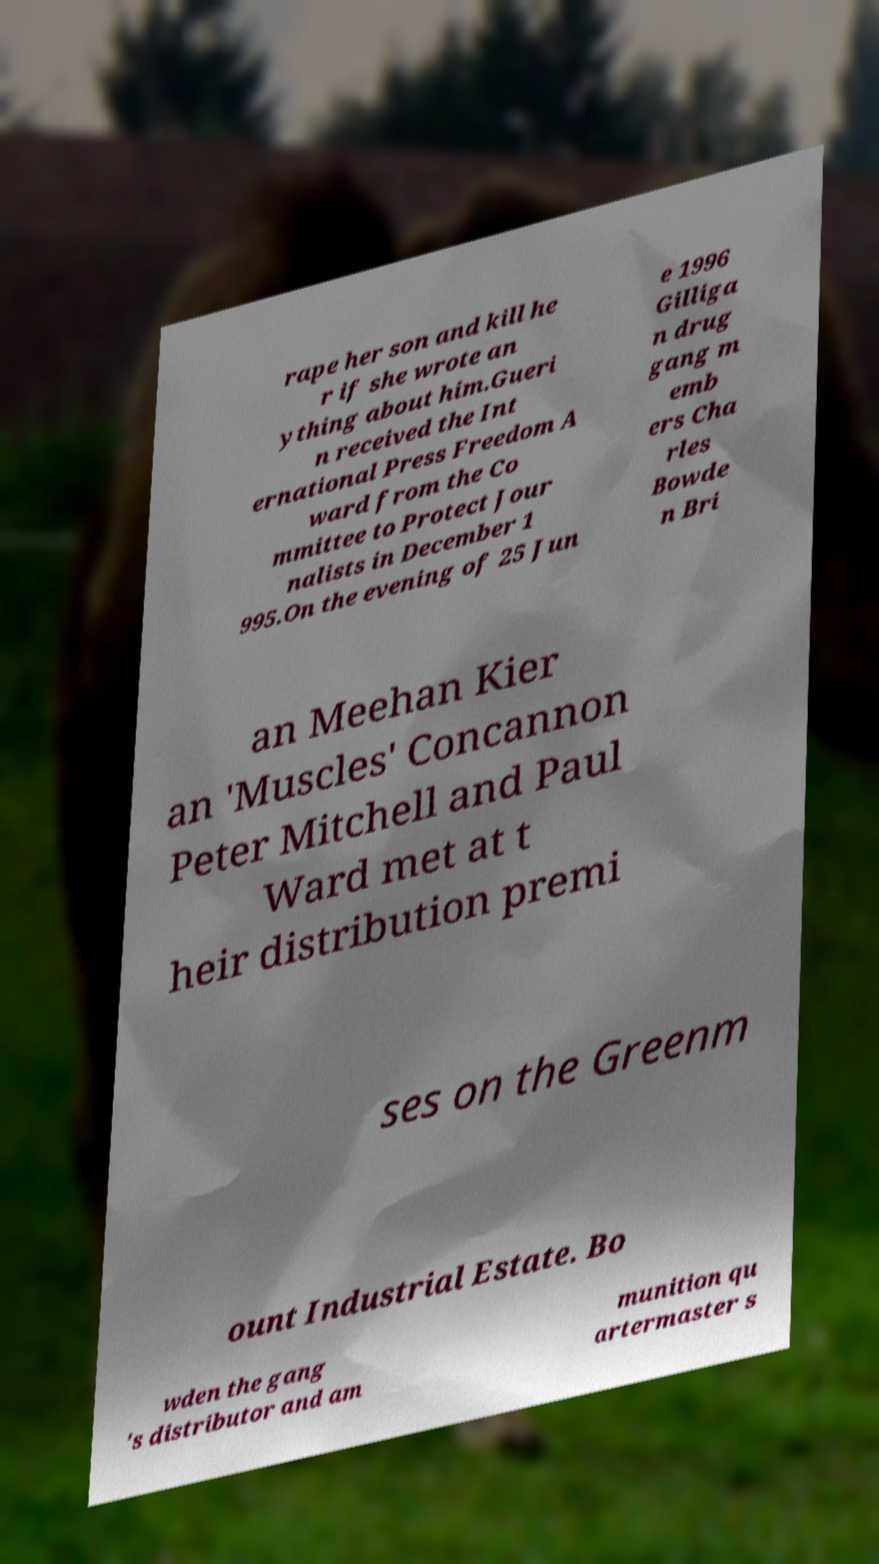Could you assist in decoding the text presented in this image and type it out clearly? rape her son and kill he r if she wrote an ything about him.Gueri n received the Int ernational Press Freedom A ward from the Co mmittee to Protect Jour nalists in December 1 995.On the evening of 25 Jun e 1996 Gilliga n drug gang m emb ers Cha rles Bowde n Bri an Meehan Kier an 'Muscles' Concannon Peter Mitchell and Paul Ward met at t heir distribution premi ses on the Greenm ount Industrial Estate. Bo wden the gang 's distributor and am munition qu artermaster s 